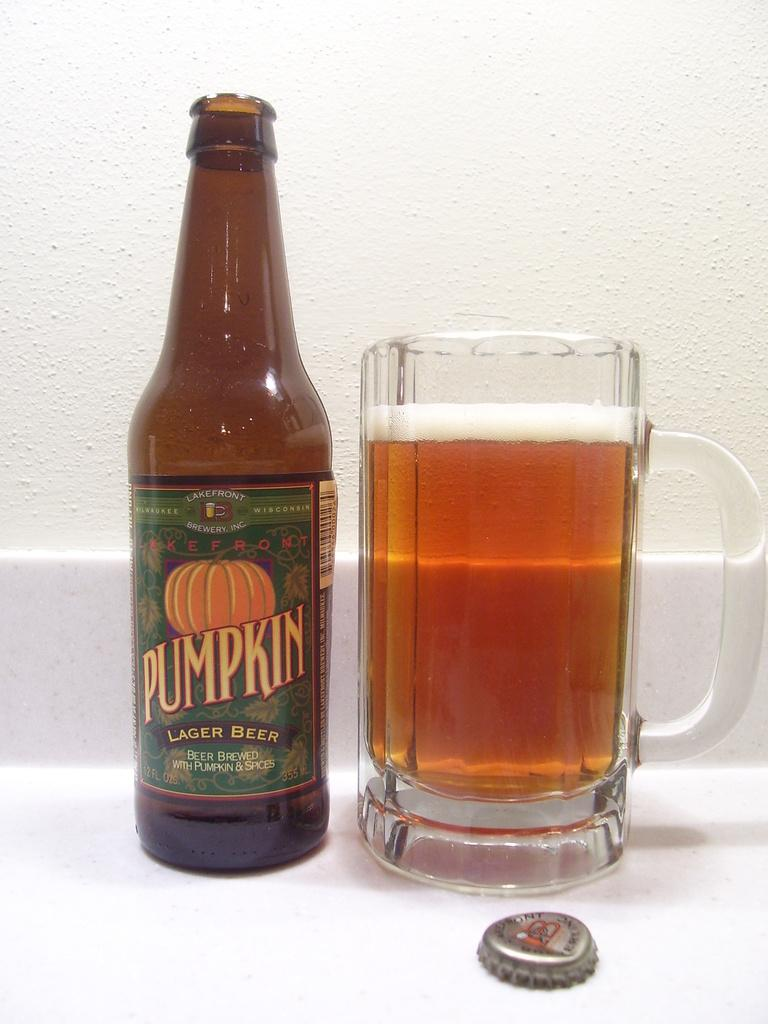<image>
Render a clear and concise summary of the photo. A bottle of pumpkin lager beer next to a full glass. 